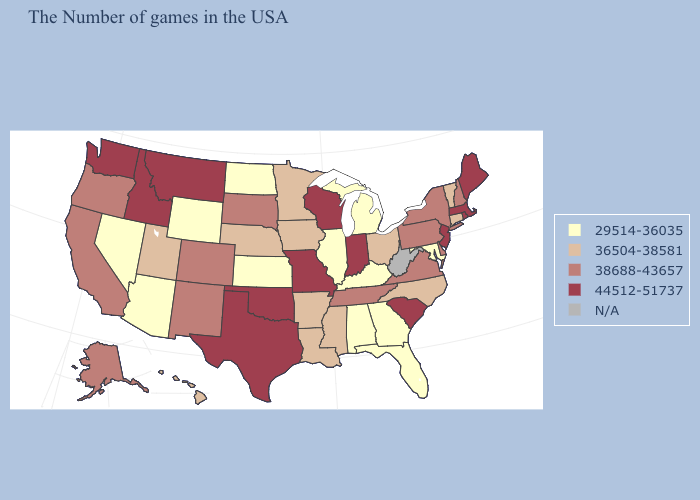Does the first symbol in the legend represent the smallest category?
Quick response, please. Yes. Does the first symbol in the legend represent the smallest category?
Concise answer only. Yes. What is the value of Minnesota?
Give a very brief answer. 36504-38581. Which states hav the highest value in the Northeast?
Keep it brief. Maine, Massachusetts, Rhode Island, New Jersey. What is the highest value in the South ?
Keep it brief. 44512-51737. Which states hav the highest value in the West?
Give a very brief answer. Montana, Idaho, Washington. What is the value of Arkansas?
Keep it brief. 36504-38581. Among the states that border Kentucky , does Illinois have the lowest value?
Be succinct. Yes. Does the map have missing data?
Give a very brief answer. Yes. What is the highest value in the USA?
Write a very short answer. 44512-51737. What is the highest value in the USA?
Keep it brief. 44512-51737. Name the states that have a value in the range 36504-38581?
Keep it brief. Vermont, Connecticut, North Carolina, Ohio, Mississippi, Louisiana, Arkansas, Minnesota, Iowa, Nebraska, Utah, Hawaii. Which states have the lowest value in the USA?
Concise answer only. Maryland, Florida, Georgia, Michigan, Kentucky, Alabama, Illinois, Kansas, North Dakota, Wyoming, Arizona, Nevada. Name the states that have a value in the range 29514-36035?
Give a very brief answer. Maryland, Florida, Georgia, Michigan, Kentucky, Alabama, Illinois, Kansas, North Dakota, Wyoming, Arizona, Nevada. Name the states that have a value in the range 38688-43657?
Write a very short answer. New Hampshire, New York, Delaware, Pennsylvania, Virginia, Tennessee, South Dakota, Colorado, New Mexico, California, Oregon, Alaska. 